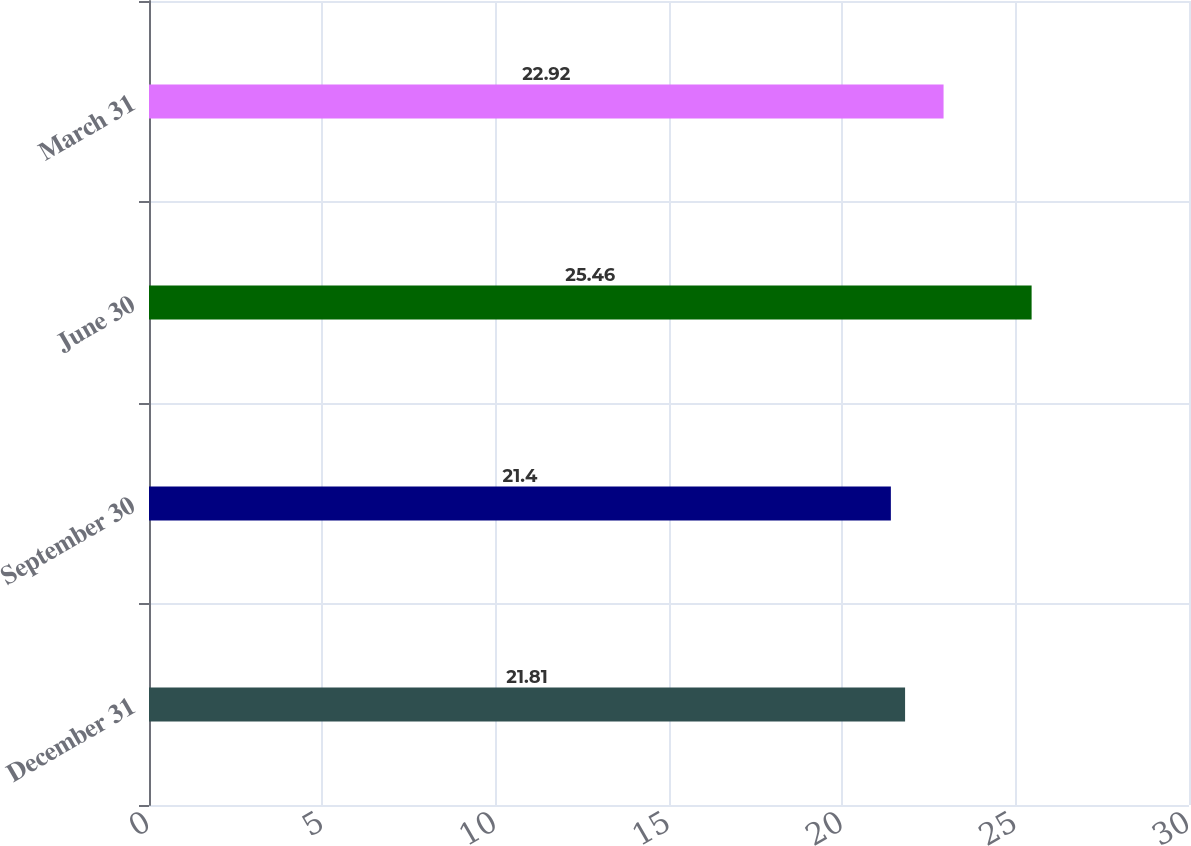<chart> <loc_0><loc_0><loc_500><loc_500><bar_chart><fcel>December 31<fcel>September 30<fcel>June 30<fcel>March 31<nl><fcel>21.81<fcel>21.4<fcel>25.46<fcel>22.92<nl></chart> 